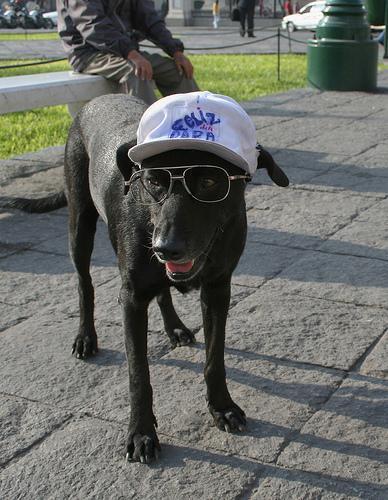How many different kinds of animals are in the photo?
Give a very brief answer. 1. 